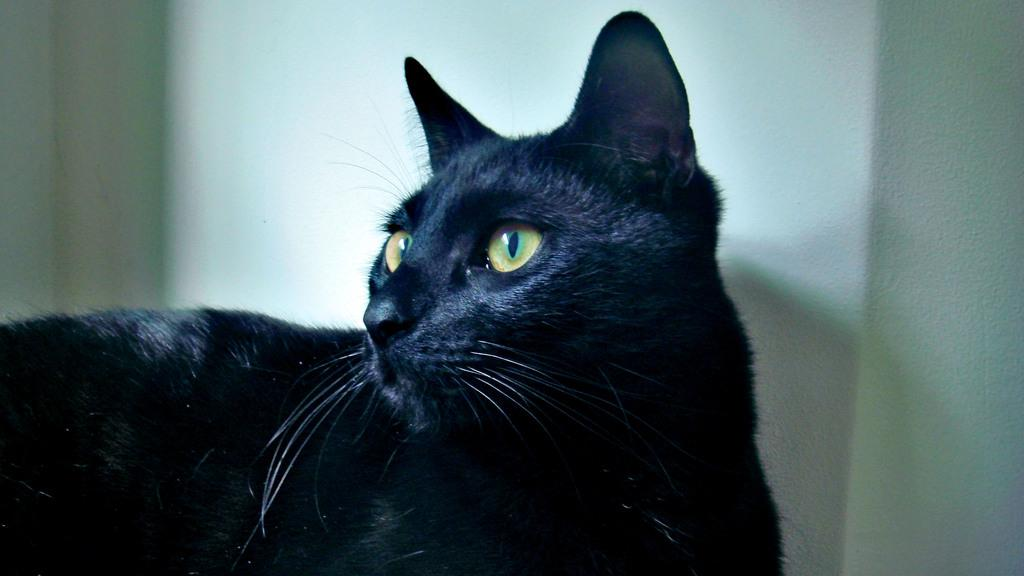What type of animal is in the image? There is a black color cat in the image. What is the color of the cat? The cat is black. What is the background color in the image? The background of the image is white. What type of plants can be seen growing in the image? There are no plants present in the image; it features a black color cat against a white background. What type of bread is visible in the image? There is no bread present in the image. 